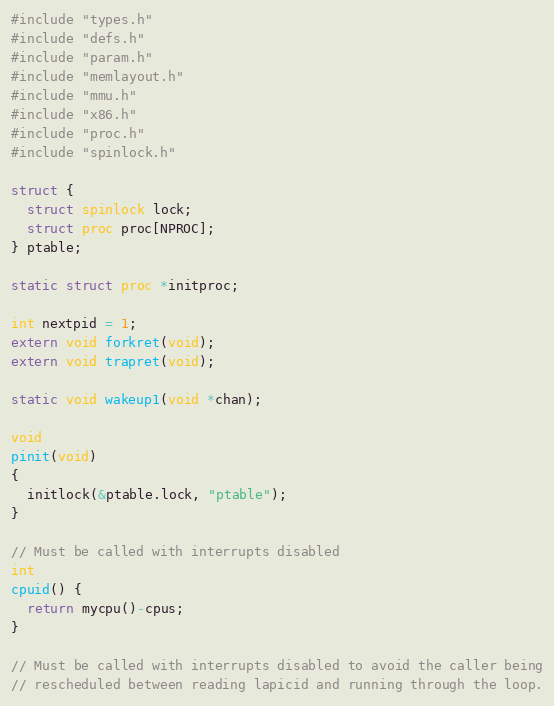<code> <loc_0><loc_0><loc_500><loc_500><_C_>#include "types.h"
#include "defs.h"
#include "param.h"
#include "memlayout.h"
#include "mmu.h"
#include "x86.h"
#include "proc.h"
#include "spinlock.h"

struct {
  struct spinlock lock;
  struct proc proc[NPROC];
} ptable;

static struct proc *initproc;

int nextpid = 1;
extern void forkret(void);
extern void trapret(void);

static void wakeup1(void *chan);

void
pinit(void)
{
  initlock(&ptable.lock, "ptable");
}

// Must be called with interrupts disabled
int
cpuid() {
  return mycpu()-cpus;
}

// Must be called with interrupts disabled to avoid the caller being
// rescheduled between reading lapicid and running through the loop.</code> 